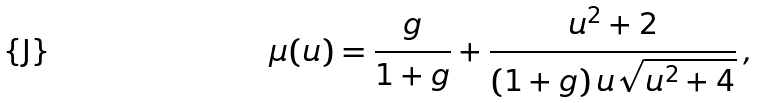Convert formula to latex. <formula><loc_0><loc_0><loc_500><loc_500>\mu ( u ) = \frac { g } { 1 + g } + \frac { u ^ { 2 } + 2 } { ( 1 + g ) \, u \sqrt { u ^ { 2 } + 4 } } \, ,</formula> 